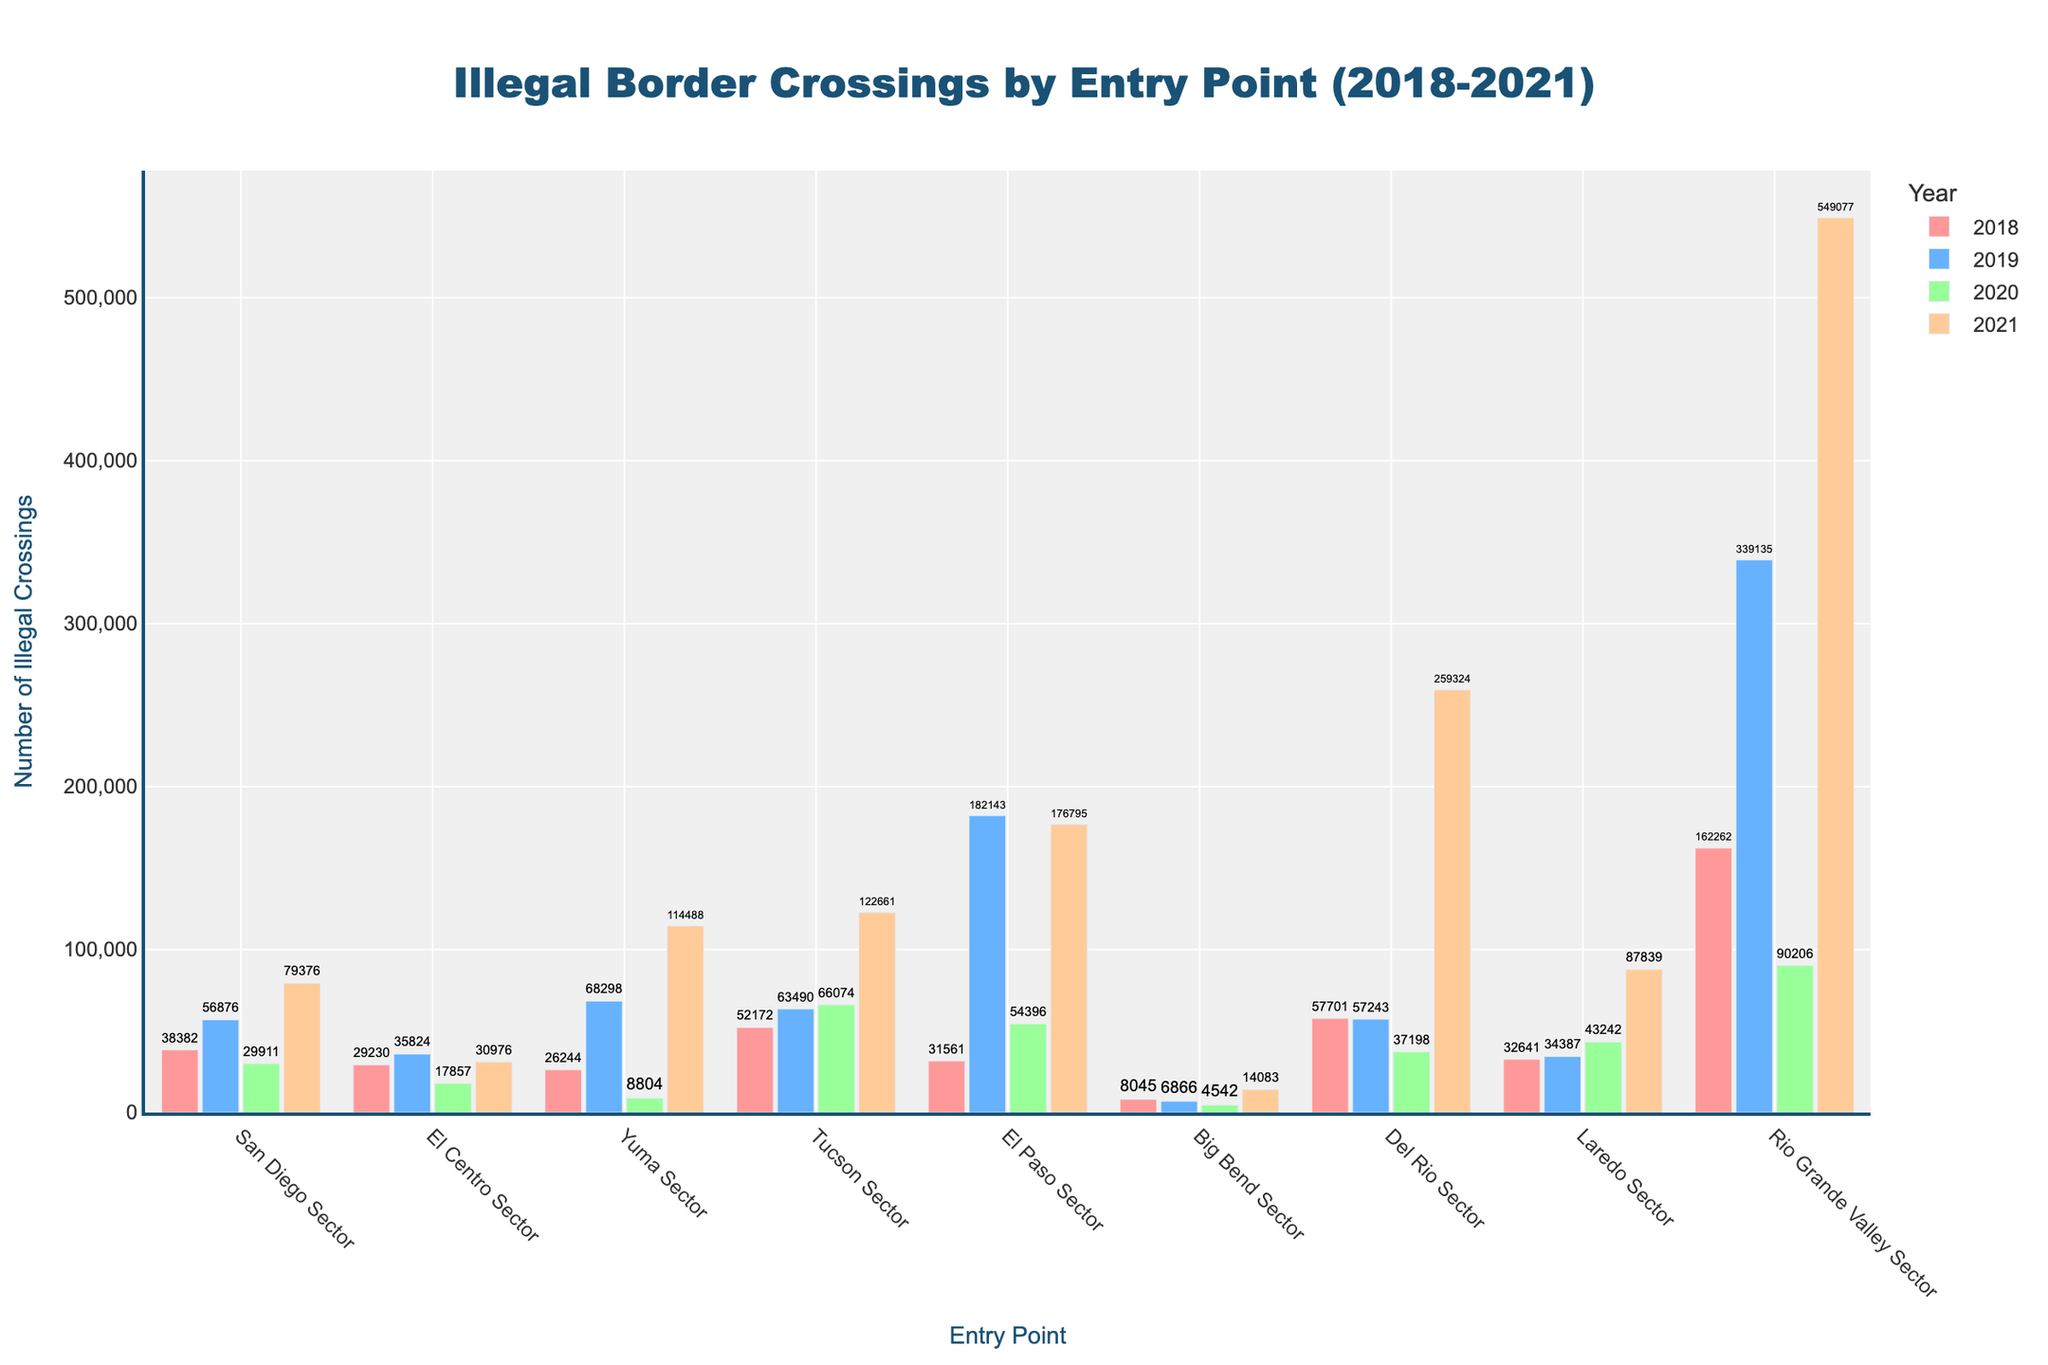What's the entry point with the highest number of illegal crossings in 2021? First, look at the bars corresponding to 2021 and identify which one is the tallest. The Rio Grande Valley Sector has the highest bar in this year, corresponding to the largest number.
Answer: Rio Grande Valley Sector How do the illegal crossings in the San Diego Sector compare between 2018 and 2021? Identify the bar heights for San Diego Sector in 2018 and 2021. In 2018, the number is lower compared to 2021. In 2021, the bar is taller.
Answer: Higher in 2021 What's the average number of illegal crossings in the El Paso Sector from 2018 to 2021? Sum the number of illegal crossings in the El Paso Sector for each year (2018: 31561, 2019: 182143, 2020: 54396, 2021: 176795) and then divide by 4. (31561 + 182143 + 54396 + 176795) / 4 = 111723.75
Answer: 111,723.75 Which year saw the highest total illegal crossings across all entry points? Add the bar heights for each entry point for each year to find the total for each year. Visually, 2021 seems to have the highest totals across multiple entry points, especially Rio Grande Valley.
Answer: 2021 In which year did the Yuma Sector see the largest increase in number of crossings compared to the previous year? Look at the bar heights for Yuma Sector across different years. The largest increase seems to be from 2019 to 2021.
Answer: 2021 What is the sum of illegal crossings for the Rio Grande Valley Sector in 2018 and 2019? Add the heights of the Rio Grande Valley bars for 2018 and 2019. (162262 + 339135) = 501397
Answer: 501,397 Which entry points consistently have the lowest number of crossings between 2018 and 2021? Look for bars that are consistently short across all years. Big Bend Sector appears to have the lowest numbers throughout these years.
Answer: Big Bend Sector What color represents the year 2019 in the bar chart? Identify the color in the legend associated with the year 2019. The bar for 2019 is represented in blue.
Answer: Blue How do the illegal crossings in the Tucson Sector change from 2018 to 2021? Compare the bar heights for Tucson Sector from 2018 to 2021. From visual inspection, crossovers rise significantly from 2018, peaking in 2021.
Answer: Increased In which year did Del Rio Sector surpass 250,000 illegal crossings? Identify the bar corresponding to Del Rio Sector each year and note the heights. In 2021, Del Rio Sector exceeded 250,000, which is higher than other years.
Answer: 2021 